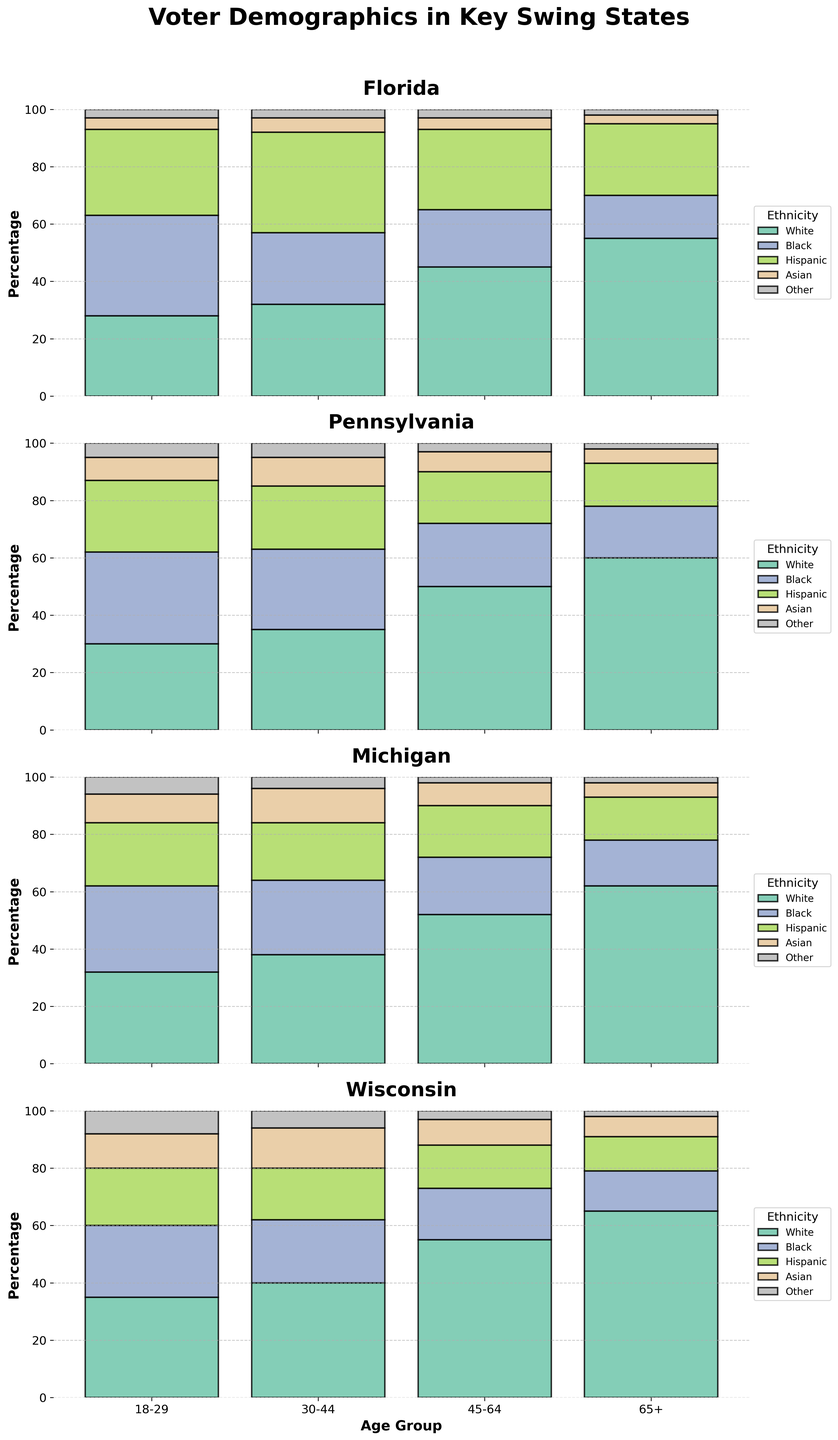What is the title of the plot? The title of the plot is displayed prominently at the top. It reads "Voter Demographics in Key Swing States". This lets viewers know the topic of the visual analysis.
Answer: Voter Demographics in Key Swing States Which state has the highest percentage of 65+ White voters? To find this, look at the bars representing the 65+ age group in each subplot. Identify the percentage of White voters in each state. Michigan has 62%, and Wisconsin has 65%.
Answer: Wisconsin In Pennsylvania, which age group has the highest percentage of Hispanic voters? Examine the different age groups for the Pennsylvania subplot. Identify the height of the Hispanic bar, which represents the percentage of Hispanic voters. Age 18-29 is 25%, age 30-44 is 22%, age 45-64 is 18%, age 65+ is 15%.
Answer: 18-29 Which state shows the smallest difference between White voter percentages in the 18-29 and 65+ age groups? Calculate the differences in percentages for each state and compare them. For Florida: 55% - 28% = 27%, Pennsylvania: 60% - 30% = 30%, Michigan: 62% - 32% = 30%, Wisconsin: 65% - 35% = 30%. Florida has the smallest difference.
Answer: Florida Which state has the largest percentage of Asian voters in the 30-44 age group? Look at each state's subplot and find the bar representing Asian voters in the 30-44 age group. Compare these values. Florida has 5%, Pennsylvania has 10%, Michigan has 12%, and Wisconsin has 14%.
Answer: Wisconsin How does the percentage of Hispanic voters in the 45-64 age group compare between Michigan and Wisconsin? Check the height of the Hispanic bars for the 45-64 age group in Michigan and Wisconsin. Michigan is 18%, and Wisconsin is 15%.
Answer: Michigan has a higher percentage What is the overall trend in the percentage of White voters by age across the states? Examine the bars for White voters in each age group, from 18-29 to 65+, across all states. The percentage increases with age in each state, showing a consistent pattern.
Answer: Increases with age For Pennsylvania, what is the combined percentage of Black and Hispanic voters in the 30-44 age group? Identify the percentages of Black (28%) and Hispanic (22%) voters in Pennsylvania for the 30-44 age group and add them together: 28% + 22% = 50%.
Answer: 50% Which ethnicity has the lowest representation in the 65+ age group across all states? Compare the heights of the bars representing each ethnicity within the 65+ age group across all subplots. Other ethnicity categories often have the lowest representation, typically around 2%.
Answer: Other 